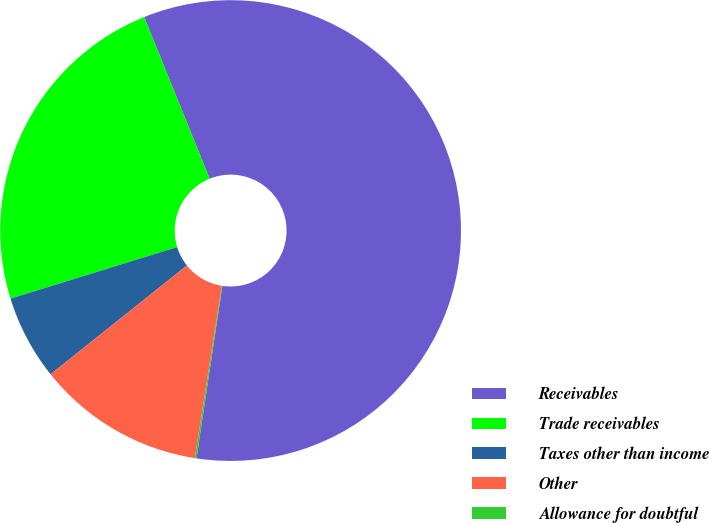<chart> <loc_0><loc_0><loc_500><loc_500><pie_chart><fcel>Receivables<fcel>Trade receivables<fcel>Taxes other than income<fcel>Other<fcel>Allowance for doubtful<nl><fcel>58.49%<fcel>23.65%<fcel>5.95%<fcel>11.79%<fcel>0.12%<nl></chart> 